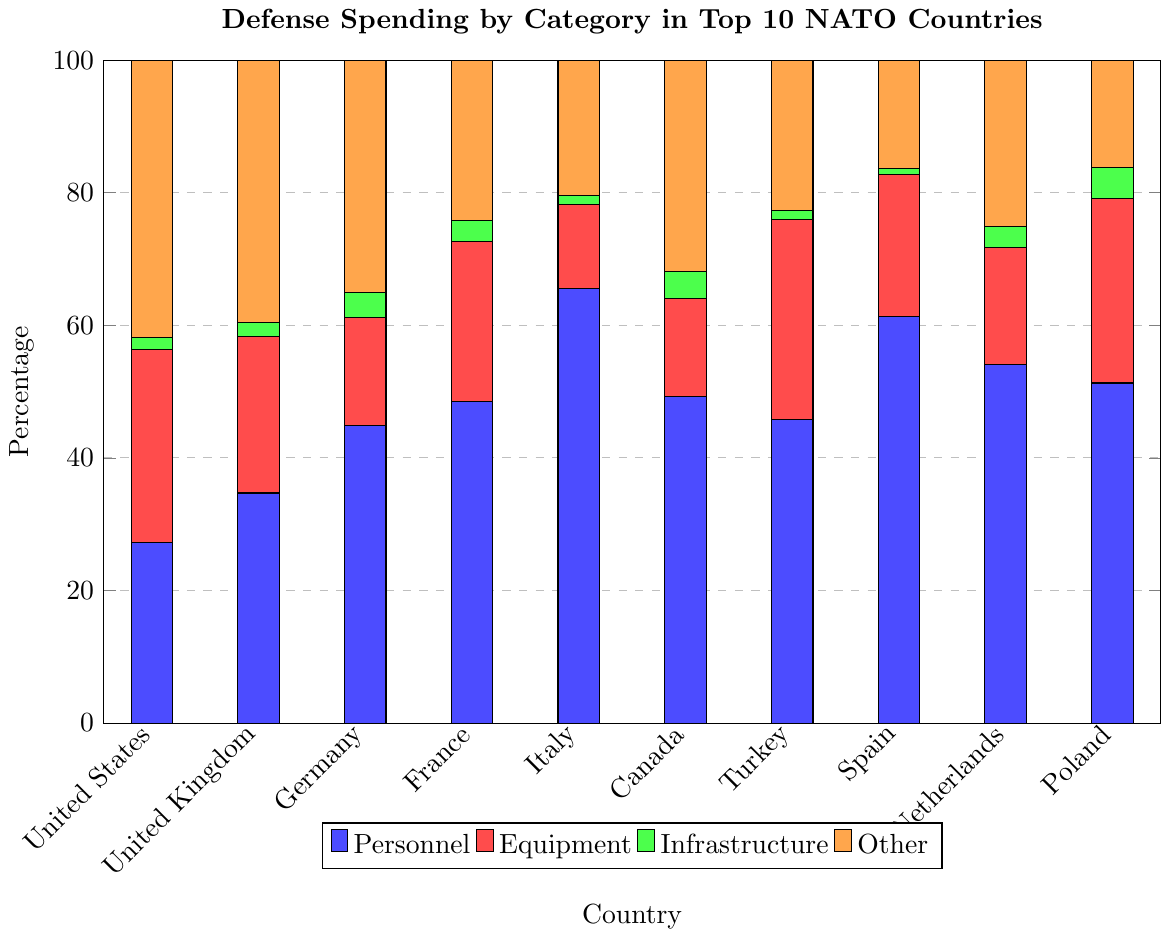Which country has the highest percentage of spending on Personnel? The highest bar in the blue section represents the country with the highest percentage of spending on Personnel. Compare the blue bars. France has the highest blue bar representing 48.5%.
Answer: France Which country has the smallest percentage of spending on Infrastructure? The smallest bar in the green section represents the country with the lowest percentage spent on Infrastructure. Compare the green bars. Spain has the smallest green bar representing 1.0%.
Answer: Spain What is the difference in percentage of spending on Equipment between Germany and Turkey? Look at the red bars for Germany (16.3%) and Turkey (30.2%). Subtract the percentage of Germany from Turkey: 30.2% - 16.3% = 13.9%.
Answer: 13.9% What is the total percentage of spending on Equipment and Infrastructure in Poland? Look at the red and green bars for Poland. Sum the values for Equipment (27.8%) and Infrastructure (4.7%): 27.8% + 4.7% = 32.5%.
Answer: 32.5% Which two countries spend the highest and lowest percentages on the 'Other' category? Compare the orange bars. The United States has the highest percentage (41.8%) and Poland has the lowest percentage (16.2%).
Answer: United States and Poland In which categories does Canada allocate more than 30% of its defense budget? Check the bars representing Canada. Blue (Personnel) is 49.2% and orange (Other) is 31.9% which are both above 30%.
Answer: Personnel and Other Which country spends approximately equal on Personnel and 'Other' categories, and what are these percentages? Look for a country where the blue and orange bars are of similar height. The United Kingdom has similar blue (34.7%) and orange (39.6%) bars.
Answer: United Kingdom, with 34.7% and 39.6% How does the Equipment spending of Italy compare to that of Canada? Compare the red bars for Italy (12.7%) and Canada (14.8%). Canada spends more on Equipment than Italy.
Answer: Canada spends more What is the average percentage spent on Infrastructure across all the countries? Add all the percentages of the green bars: 1.8% + 2.1% + 3.8% + 3.1% + 1.4% + 4.1% + 1.3% + 1.0% + 3.2% + 4.7% = 26.5%. Divide by the number of countries (10): 26.5% / 10 = 2.65%.
Answer: 2.65% If a new country with equal percentages in all four categories were added, what would each percentage be? To have equal distribution in 4 categories, each category would get 100% / 4 = 25%.
Answer: 25% for each category 